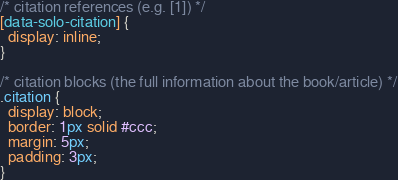Convert code to text. <code><loc_0><loc_0><loc_500><loc_500><_CSS_>/* citation references (e.g. [1]) */
[data-solo-citation] {
  display: inline;
}

/* citation blocks (the full information about the book/article) */
.citation {
  display: block;
  border: 1px solid #ccc;
  margin: 5px;
  padding: 3px;
}
</code> 